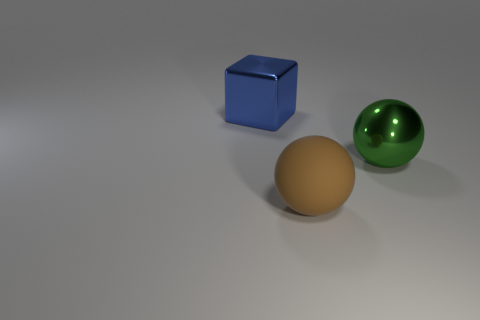There is a large shiny object left of the large shiny thing right of the blue thing; what number of brown objects are right of it?
Provide a succinct answer. 1. What number of objects are both behind the brown ball and right of the large blue shiny object?
Provide a short and direct response. 1. Are there more matte things that are to the right of the metal ball than green metal cubes?
Provide a succinct answer. No. How many green metal spheres are the same size as the shiny block?
Provide a short and direct response. 1. How many tiny objects are either brown things or gray rubber cylinders?
Provide a short and direct response. 0. What number of yellow metallic cylinders are there?
Provide a short and direct response. 0. Are there an equal number of blue shiny objects in front of the large green metal ball and brown matte balls in front of the big blue cube?
Your response must be concise. No. There is a big blue shiny object; are there any large shiny cubes on the left side of it?
Offer a very short reply. No. There is a big shiny thing that is left of the big brown rubber thing; what color is it?
Provide a short and direct response. Blue. What is the material of the large thing that is left of the large ball that is in front of the green ball?
Ensure brevity in your answer.  Metal. 